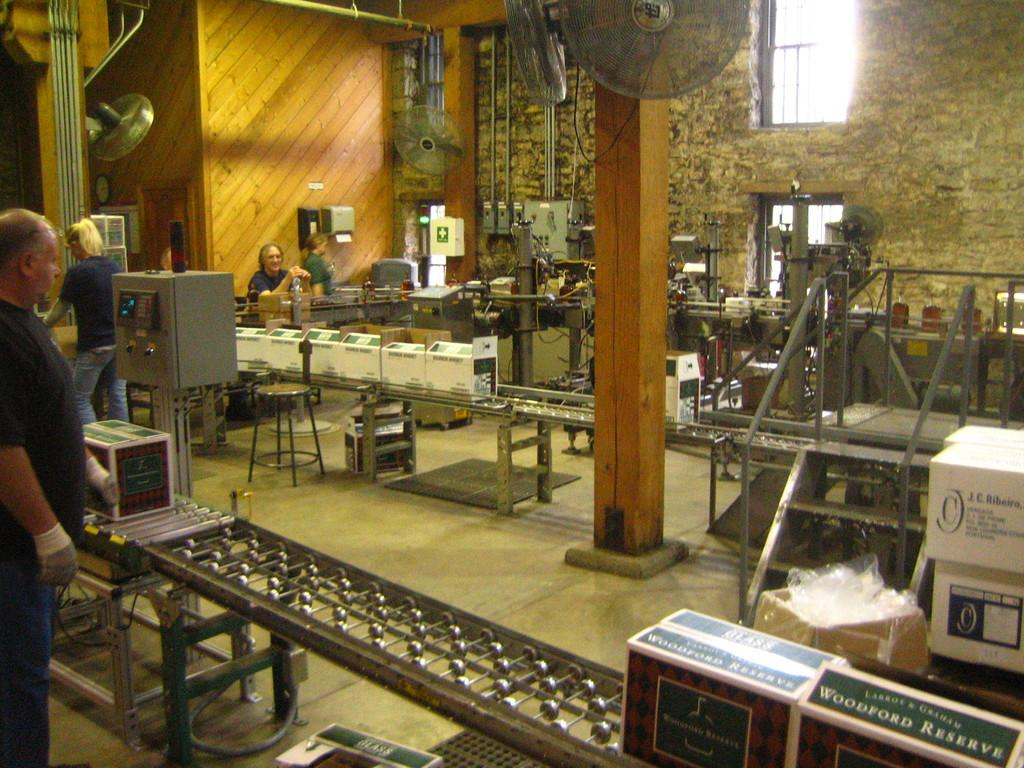<image>
Share a concise interpretation of the image provided. A bunch of people working in an assembly line packaging woodford reserve. 